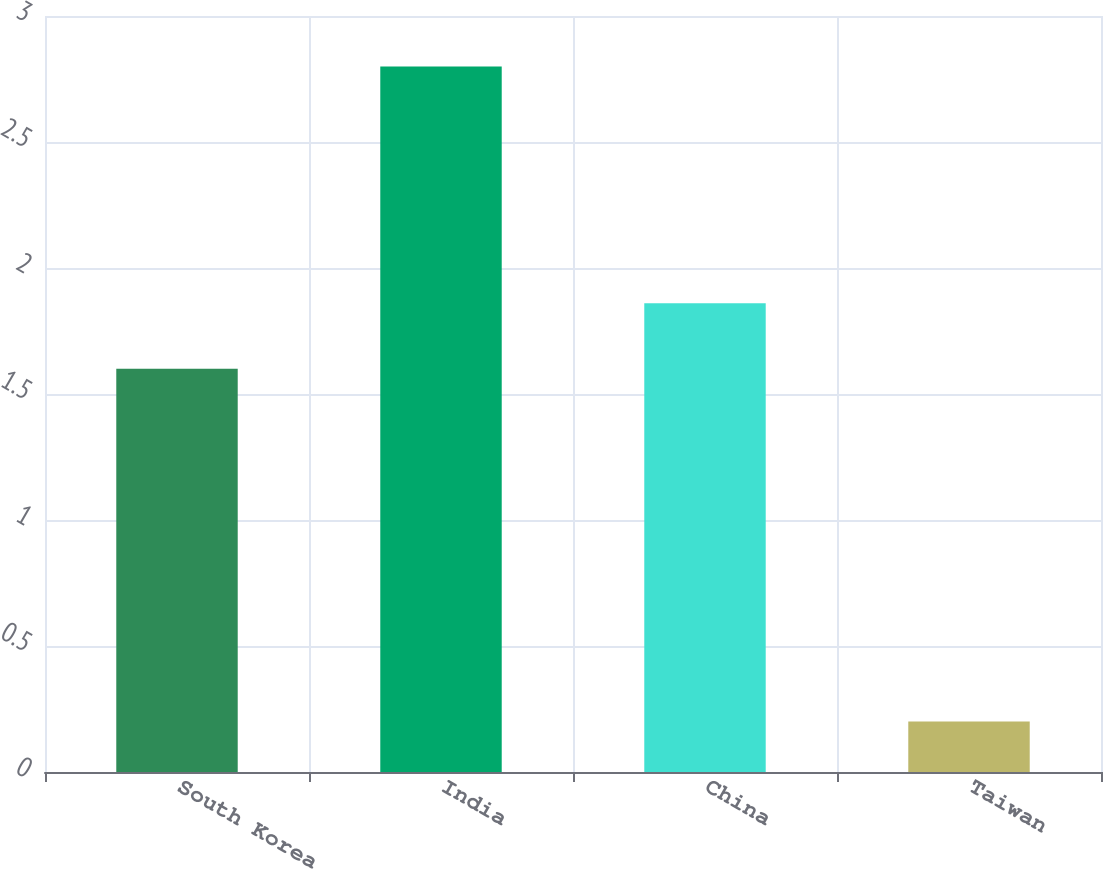Convert chart. <chart><loc_0><loc_0><loc_500><loc_500><bar_chart><fcel>South Korea<fcel>India<fcel>China<fcel>Taiwan<nl><fcel>1.6<fcel>2.8<fcel>1.86<fcel>0.2<nl></chart> 